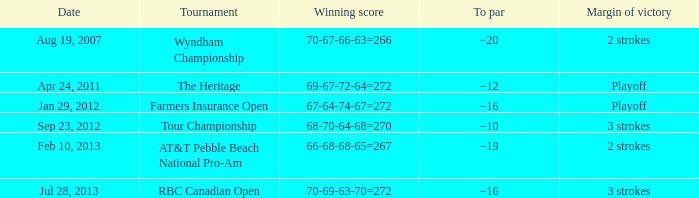Would you be able to parse every entry in this table? {'header': ['Date', 'Tournament', 'Winning score', 'To par', 'Margin of victory'], 'rows': [['Aug 19, 2007', 'Wyndham Championship', '70-67-66-63=266', '−20', '2 strokes'], ['Apr 24, 2011', 'The Heritage', '69-67-72-64=272', '−12', 'Playoff'], ['Jan 29, 2012', 'Farmers Insurance Open', '67-64-74-67=272', '−16', 'Playoff'], ['Sep 23, 2012', 'Tour Championship', '68-70-64-68=270', '−10', '3 strokes'], ['Feb 10, 2013', 'AT&T Pebble Beach National Pro-Am', '66-68-68-65=267', '−19', '2 strokes'], ['Jul 28, 2013', 'RBC Canadian Open', '70-69-63-70=272', '−16', '3 strokes']]} What is the to par of the match with a winning score 69-67-72-64=272? −12. 